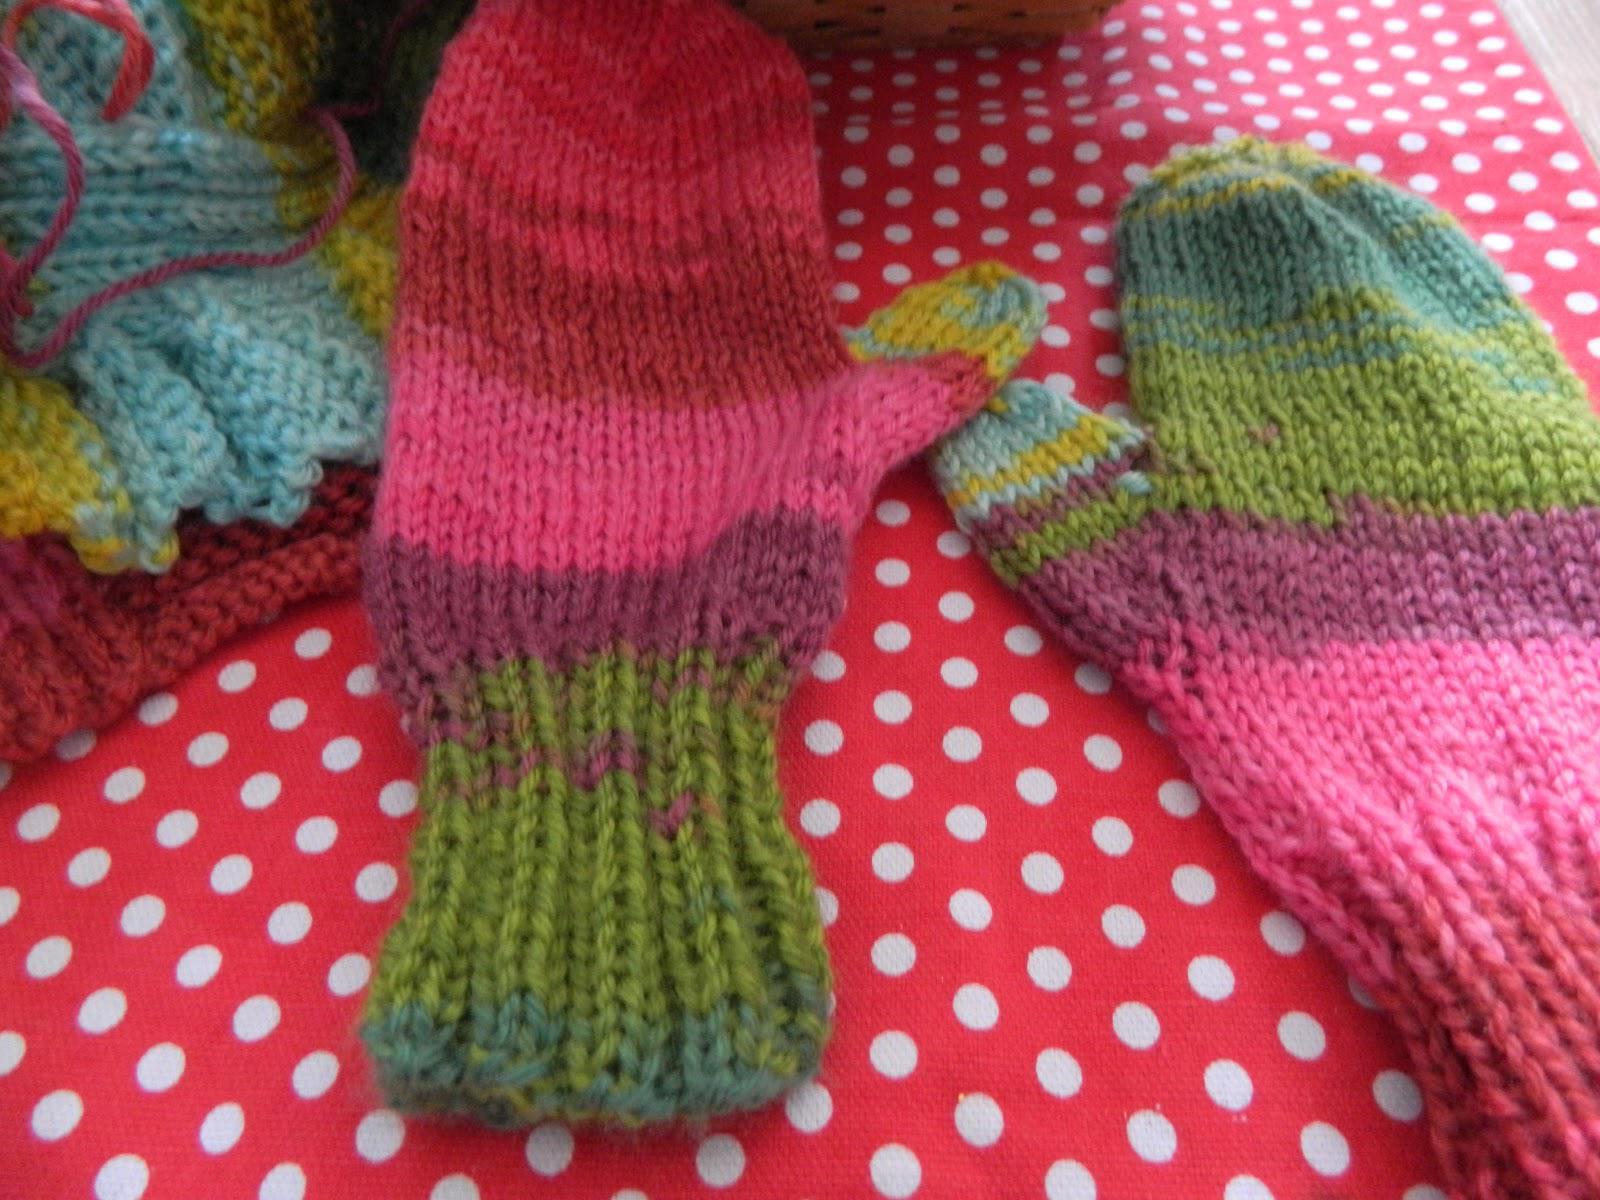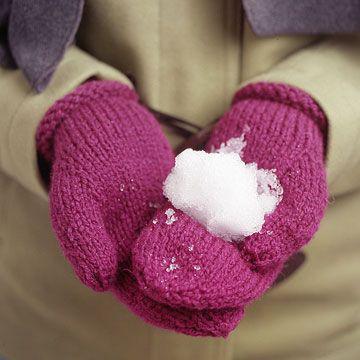The first image is the image on the left, the second image is the image on the right. Assess this claim about the two images: "The mittens in the image on the right have hands in them.". Correct or not? Answer yes or no. Yes. 